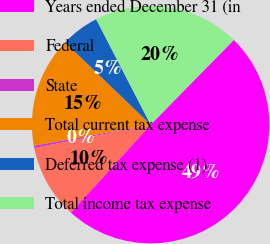<chart> <loc_0><loc_0><loc_500><loc_500><pie_chart><fcel>Years ended December 31 (in<fcel>Federal<fcel>State<fcel>Total current tax expense<fcel>Deferred tax expense (1)<fcel>Total income tax expense<nl><fcel>49.38%<fcel>10.12%<fcel>0.31%<fcel>15.03%<fcel>5.22%<fcel>19.94%<nl></chart> 